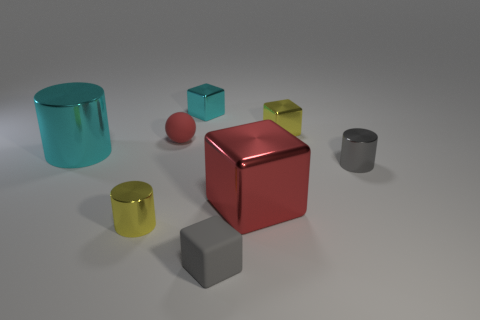Is there anything else that is the same material as the cyan cylinder?
Give a very brief answer. Yes. How many things are either cylinders that are on the right side of the cyan metallic cube or cyan things to the right of the small red thing?
Keep it short and to the point. 2. What color is the large object that is the same shape as the tiny cyan metal thing?
Ensure brevity in your answer.  Red. Are there any other things that are the same shape as the large cyan thing?
Your answer should be compact. Yes. There is a tiny red thing; is it the same shape as the tiny gray metallic thing behind the rubber block?
Your answer should be compact. No. What is the ball made of?
Your response must be concise. Rubber. There is a red thing that is the same shape as the small cyan object; what is its size?
Give a very brief answer. Large. What number of other objects are there of the same material as the red ball?
Ensure brevity in your answer.  1. Are the gray cube and the cylinder that is behind the tiny gray cylinder made of the same material?
Keep it short and to the point. No. Is the number of cyan metal cylinders right of the tiny red rubber thing less than the number of big red things that are in front of the tiny cyan cube?
Provide a short and direct response. Yes. 